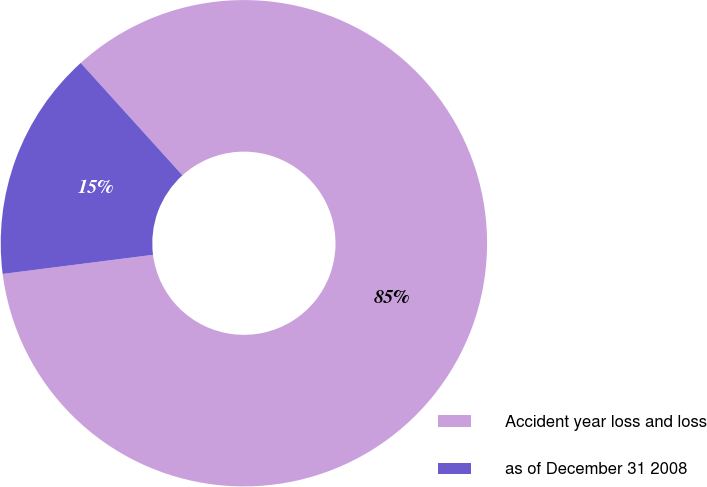<chart> <loc_0><loc_0><loc_500><loc_500><pie_chart><fcel>Accident year loss and loss<fcel>as of December 31 2008<nl><fcel>84.69%<fcel>15.31%<nl></chart> 